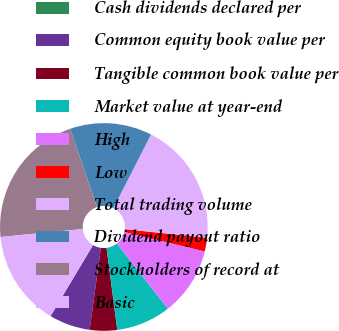<chart> <loc_0><loc_0><loc_500><loc_500><pie_chart><fcel>Cash dividends declared per<fcel>Common equity book value per<fcel>Tangible common book value per<fcel>Market value at year-end<fcel>High<fcel>Low<fcel>Total trading volume<fcel>Dividend payout ratio<fcel>Stockholders of record at<fcel>Basic<nl><fcel>0.0%<fcel>6.38%<fcel>4.26%<fcel>8.51%<fcel>10.64%<fcel>2.13%<fcel>19.15%<fcel>12.77%<fcel>21.28%<fcel>14.89%<nl></chart> 